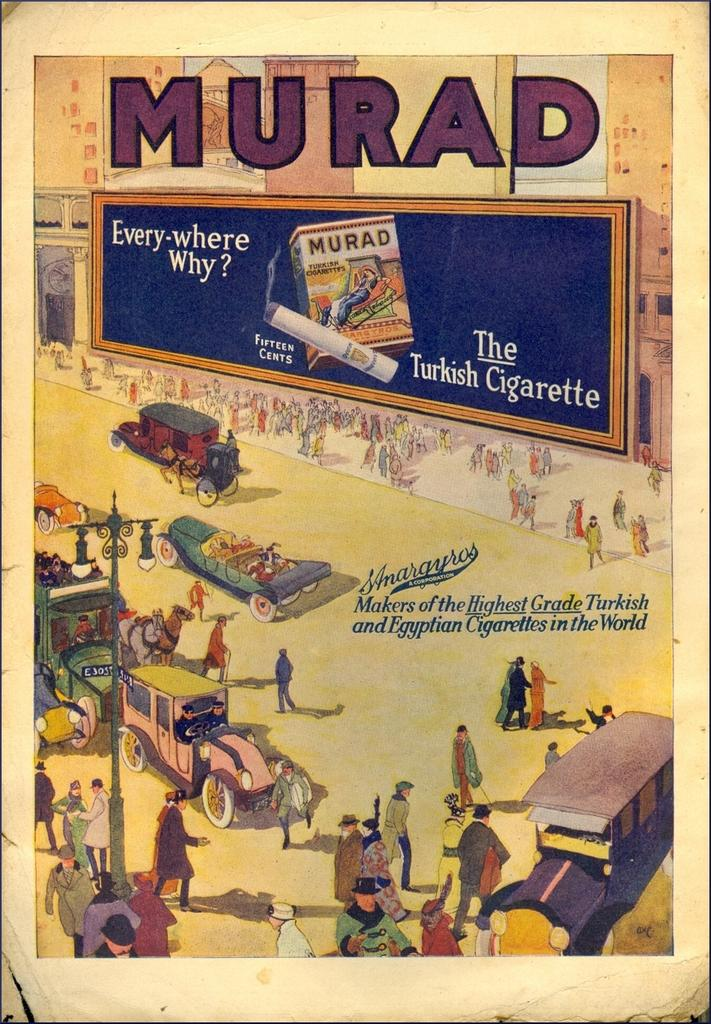Provide a one-sentence caption for the provided image. Poster with people walking outdoors and says MURAD on top. 